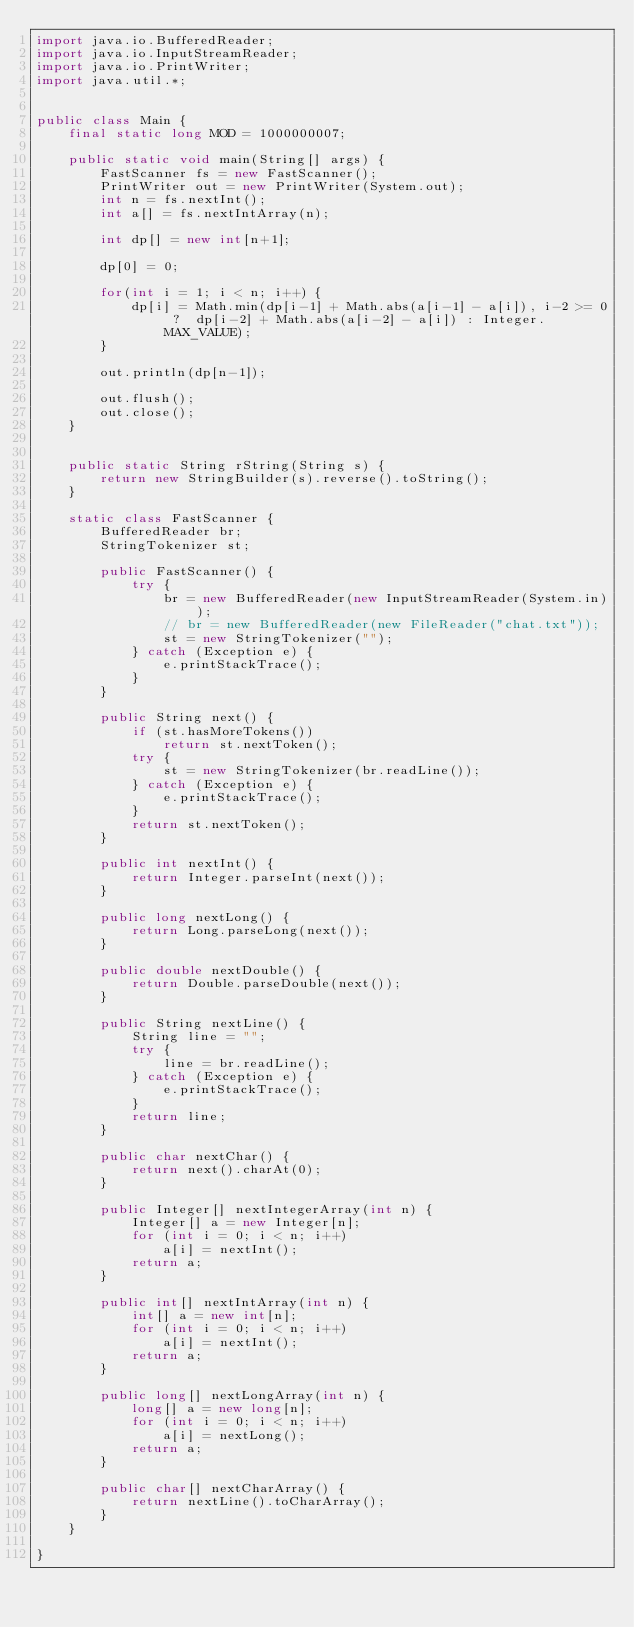<code> <loc_0><loc_0><loc_500><loc_500><_Java_>import java.io.BufferedReader;
import java.io.InputStreamReader;
import java.io.PrintWriter;
import java.util.*;


public class Main {
    final static long MOD = 1000000007;

    public static void main(String[] args) {
        FastScanner fs = new FastScanner();
        PrintWriter out = new PrintWriter(System.out);
        int n = fs.nextInt();
        int a[] = fs.nextIntArray(n);

        int dp[] = new int[n+1];

        dp[0] = 0;

        for(int i = 1; i < n; i++) {
            dp[i] = Math.min(dp[i-1] + Math.abs(a[i-1] - a[i]), i-2 >= 0 ?  dp[i-2] + Math.abs(a[i-2] - a[i]) : Integer.MAX_VALUE);
        }

        out.println(dp[n-1]);

        out.flush();
        out.close();
    }


    public static String rString(String s) {
        return new StringBuilder(s).reverse().toString();
    }

    static class FastScanner {
        BufferedReader br;
        StringTokenizer st;

        public FastScanner() {
            try {
                br = new BufferedReader(new InputStreamReader(System.in));
                // br = new BufferedReader(new FileReader("chat.txt"));
                st = new StringTokenizer("");
            } catch (Exception e) {
                e.printStackTrace();
            }
        }

        public String next() {
            if (st.hasMoreTokens())
                return st.nextToken();
            try {
                st = new StringTokenizer(br.readLine());
            } catch (Exception e) {
                e.printStackTrace();
            }
            return st.nextToken();
        }

        public int nextInt() {
            return Integer.parseInt(next());
        }

        public long nextLong() {
            return Long.parseLong(next());
        }

        public double nextDouble() {
            return Double.parseDouble(next());
        }

        public String nextLine() {
            String line = "";
            try {
                line = br.readLine();
            } catch (Exception e) {
                e.printStackTrace();
            }
            return line;
        }

        public char nextChar() {
            return next().charAt(0);
        }

        public Integer[] nextIntegerArray(int n) {
            Integer[] a = new Integer[n];
            for (int i = 0; i < n; i++)
                a[i] = nextInt();
            return a;
        }

        public int[] nextIntArray(int n) {
            int[] a = new int[n];
            for (int i = 0; i < n; i++)
                a[i] = nextInt();
            return a;
        }

        public long[] nextLongArray(int n) {
            long[] a = new long[n];
            for (int i = 0; i < n; i++)
                a[i] = nextLong();
            return a;
        }

        public char[] nextCharArray() {
            return nextLine().toCharArray();
        }
    }

}



</code> 